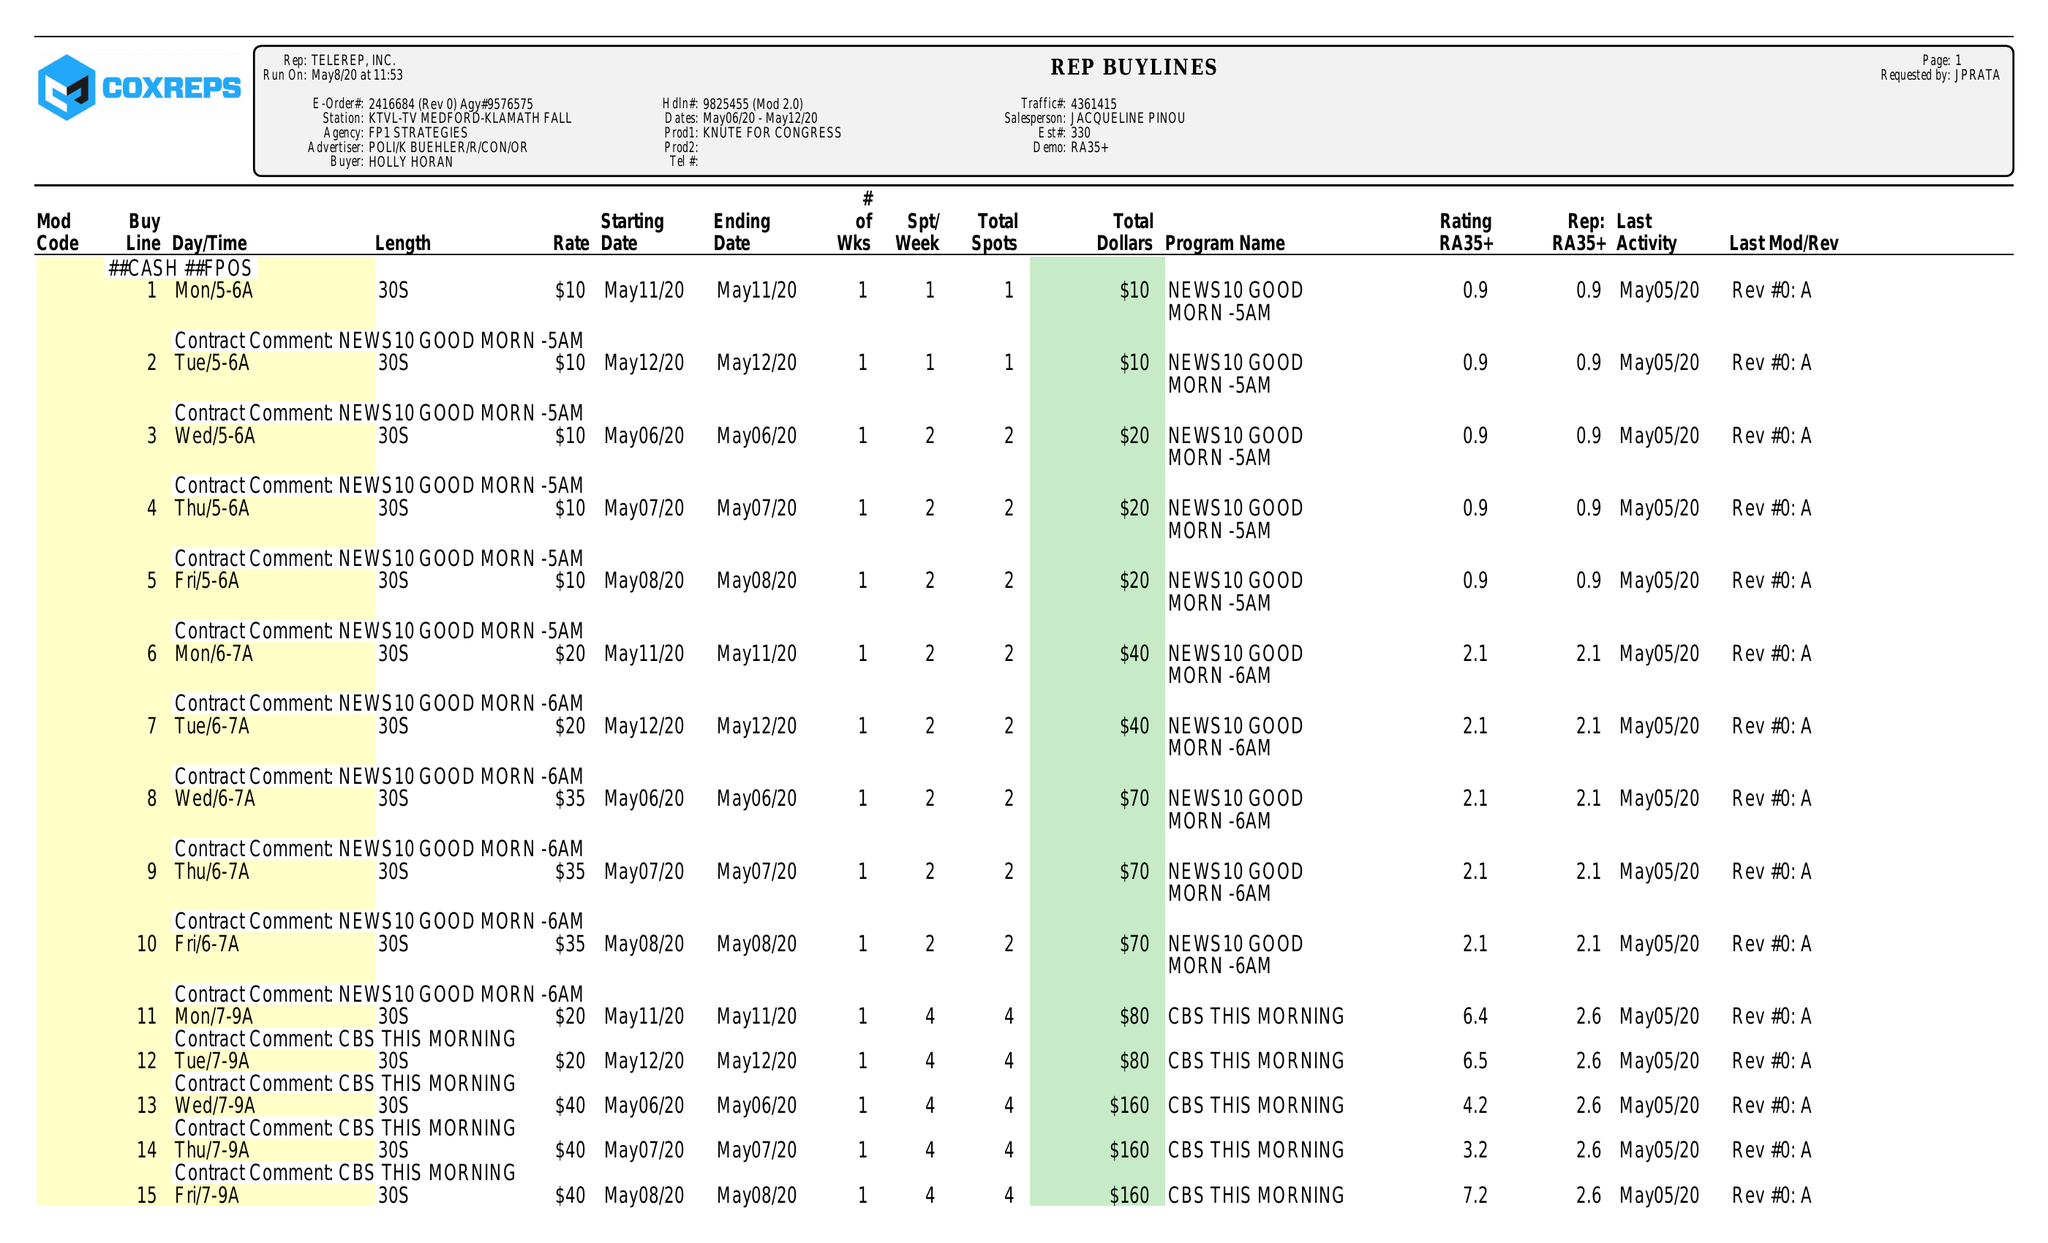What is the value for the flight_to?
Answer the question using a single word or phrase. 05/12/20 